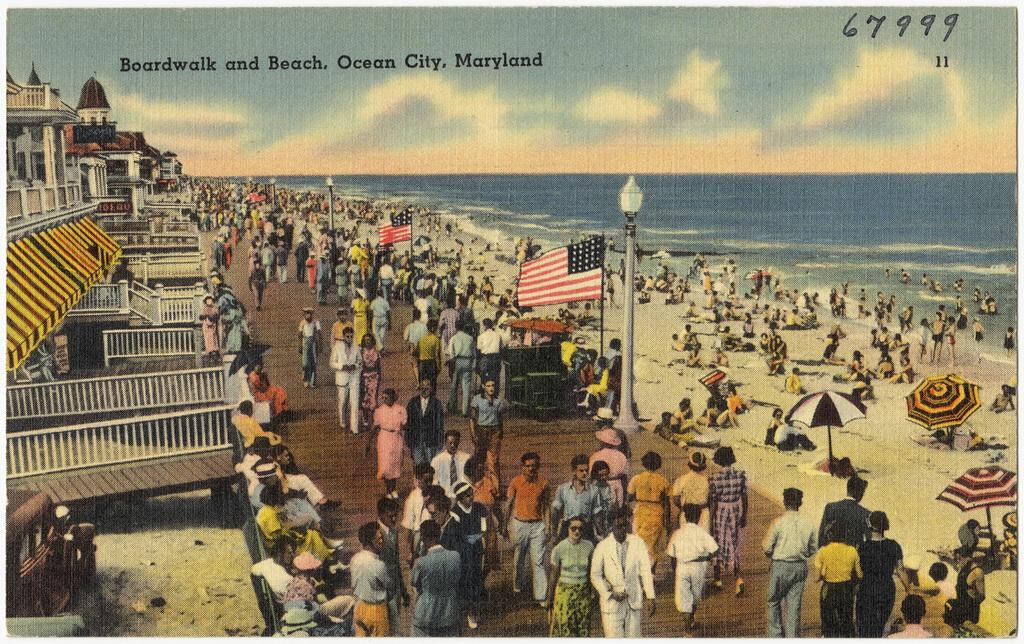<image>
Share a concise interpretation of the image provided. A postcard of the boardwalk in Ocean City Maryland. 